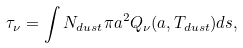<formula> <loc_0><loc_0><loc_500><loc_500>\tau _ { \nu } = \int N _ { d u s t } \pi a ^ { 2 } Q _ { \nu } ( a , T _ { d u s t } ) d s ,</formula> 